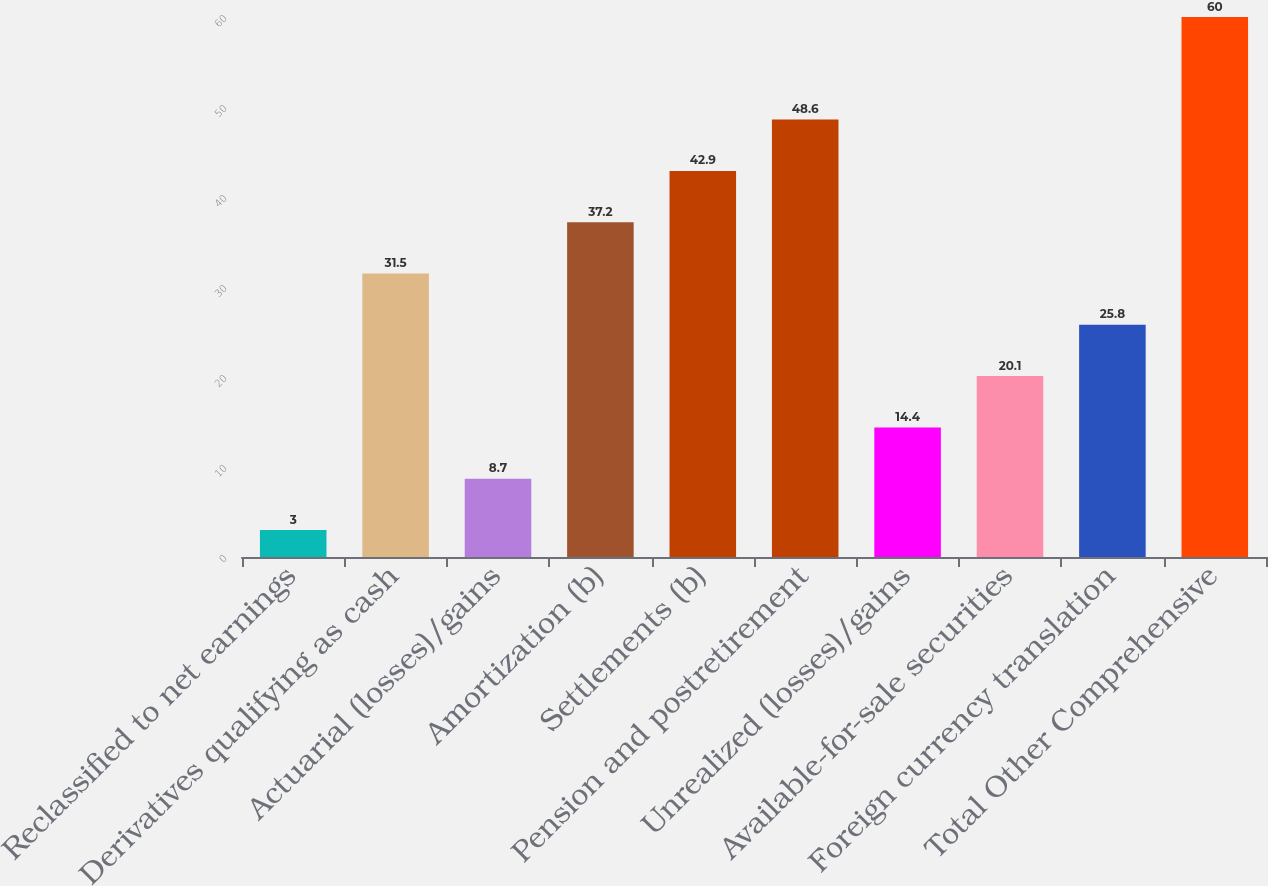Convert chart to OTSL. <chart><loc_0><loc_0><loc_500><loc_500><bar_chart><fcel>Reclassified to net earnings<fcel>Derivatives qualifying as cash<fcel>Actuarial (losses)/gains<fcel>Amortization (b)<fcel>Settlements (b)<fcel>Pension and postretirement<fcel>Unrealized (losses)/gains<fcel>Available-for-sale securities<fcel>Foreign currency translation<fcel>Total Other Comprehensive<nl><fcel>3<fcel>31.5<fcel>8.7<fcel>37.2<fcel>42.9<fcel>48.6<fcel>14.4<fcel>20.1<fcel>25.8<fcel>60<nl></chart> 